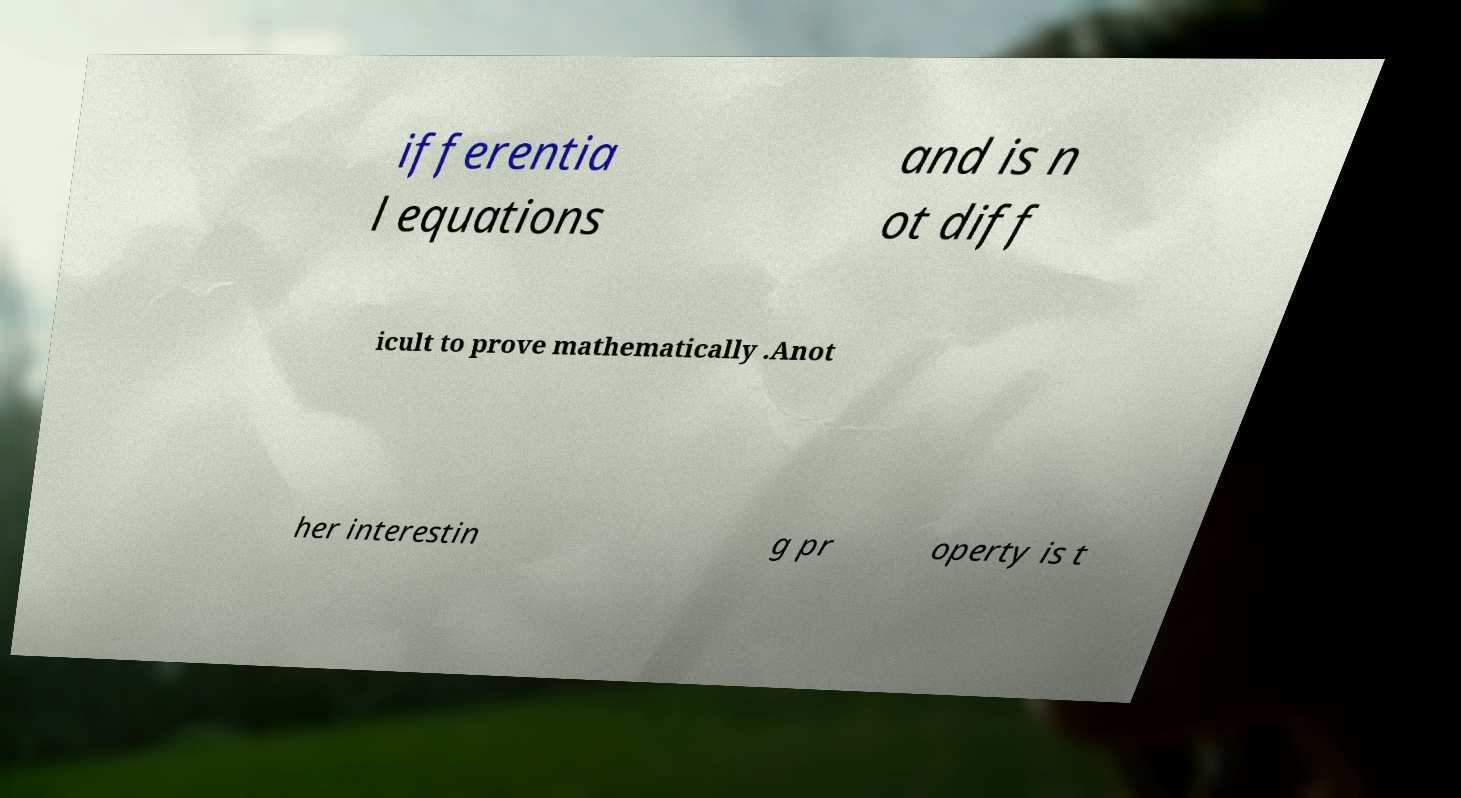Could you assist in decoding the text presented in this image and type it out clearly? ifferentia l equations and is n ot diff icult to prove mathematically .Anot her interestin g pr operty is t 